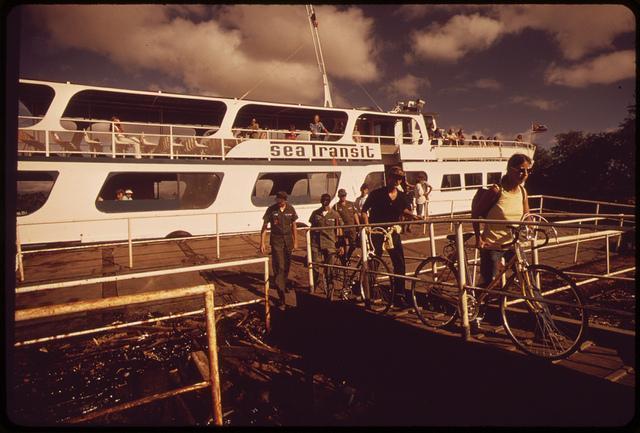How many vehicles are pictured?
Give a very brief answer. 3. How many people are there?
Give a very brief answer. 4. How many bicycles are in the picture?
Give a very brief answer. 2. 